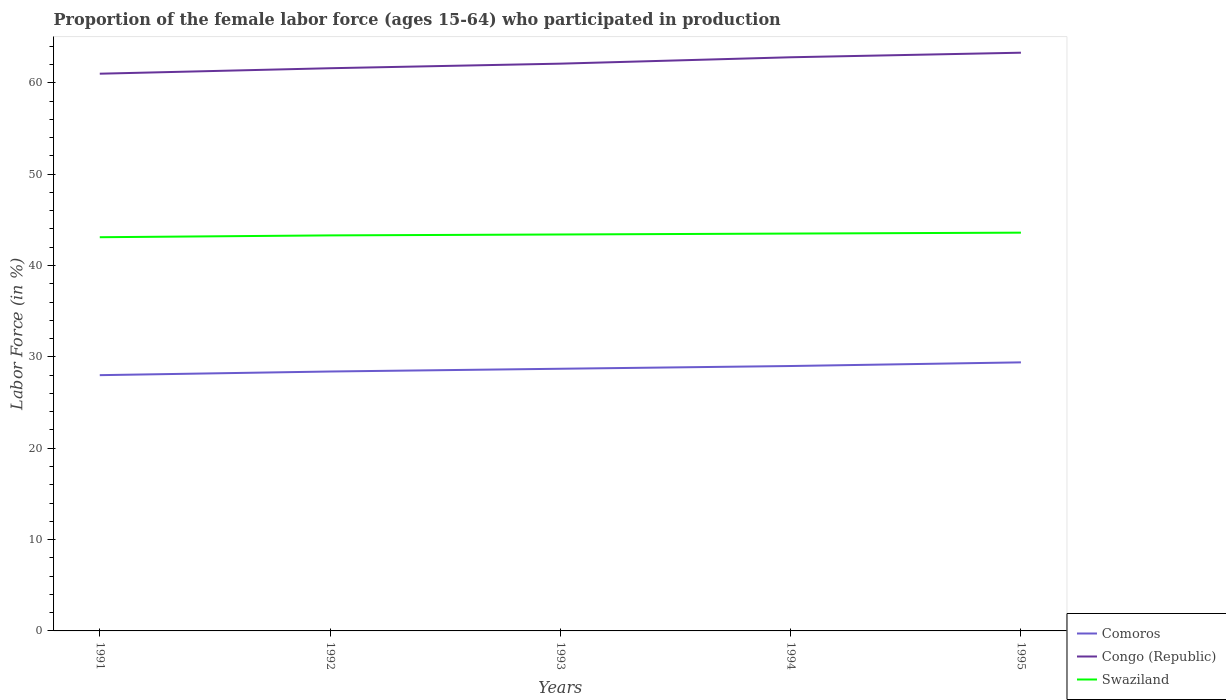Does the line corresponding to Comoros intersect with the line corresponding to Swaziland?
Keep it short and to the point. No. Is the number of lines equal to the number of legend labels?
Provide a succinct answer. Yes. Across all years, what is the maximum proportion of the female labor force who participated in production in Swaziland?
Provide a short and direct response. 43.1. In which year was the proportion of the female labor force who participated in production in Comoros maximum?
Make the answer very short. 1991. What is the total proportion of the female labor force who participated in production in Congo (Republic) in the graph?
Make the answer very short. -0.5. What is the difference between the highest and the second highest proportion of the female labor force who participated in production in Swaziland?
Keep it short and to the point. 0.5. How many legend labels are there?
Offer a terse response. 3. What is the title of the graph?
Your answer should be very brief. Proportion of the female labor force (ages 15-64) who participated in production. What is the label or title of the X-axis?
Provide a short and direct response. Years. What is the Labor Force (in %) of Swaziland in 1991?
Offer a very short reply. 43.1. What is the Labor Force (in %) in Comoros in 1992?
Your answer should be compact. 28.4. What is the Labor Force (in %) in Congo (Republic) in 1992?
Offer a very short reply. 61.6. What is the Labor Force (in %) in Swaziland in 1992?
Your answer should be compact. 43.3. What is the Labor Force (in %) in Comoros in 1993?
Make the answer very short. 28.7. What is the Labor Force (in %) of Congo (Republic) in 1993?
Provide a succinct answer. 62.1. What is the Labor Force (in %) in Swaziland in 1993?
Your answer should be compact. 43.4. What is the Labor Force (in %) in Congo (Republic) in 1994?
Offer a very short reply. 62.8. What is the Labor Force (in %) of Swaziland in 1994?
Give a very brief answer. 43.5. What is the Labor Force (in %) in Comoros in 1995?
Give a very brief answer. 29.4. What is the Labor Force (in %) of Congo (Republic) in 1995?
Keep it short and to the point. 63.3. What is the Labor Force (in %) in Swaziland in 1995?
Offer a very short reply. 43.6. Across all years, what is the maximum Labor Force (in %) of Comoros?
Keep it short and to the point. 29.4. Across all years, what is the maximum Labor Force (in %) of Congo (Republic)?
Your answer should be very brief. 63.3. Across all years, what is the maximum Labor Force (in %) in Swaziland?
Keep it short and to the point. 43.6. Across all years, what is the minimum Labor Force (in %) in Comoros?
Your response must be concise. 28. Across all years, what is the minimum Labor Force (in %) in Congo (Republic)?
Your answer should be very brief. 61. Across all years, what is the minimum Labor Force (in %) of Swaziland?
Offer a terse response. 43.1. What is the total Labor Force (in %) of Comoros in the graph?
Provide a succinct answer. 143.5. What is the total Labor Force (in %) of Congo (Republic) in the graph?
Your answer should be very brief. 310.8. What is the total Labor Force (in %) of Swaziland in the graph?
Your answer should be compact. 216.9. What is the difference between the Labor Force (in %) in Comoros in 1991 and that in 1992?
Keep it short and to the point. -0.4. What is the difference between the Labor Force (in %) of Congo (Republic) in 1991 and that in 1992?
Offer a terse response. -0.6. What is the difference between the Labor Force (in %) of Swaziland in 1991 and that in 1992?
Ensure brevity in your answer.  -0.2. What is the difference between the Labor Force (in %) in Comoros in 1991 and that in 1993?
Provide a succinct answer. -0.7. What is the difference between the Labor Force (in %) of Congo (Republic) in 1991 and that in 1993?
Offer a very short reply. -1.1. What is the difference between the Labor Force (in %) of Swaziland in 1991 and that in 1993?
Make the answer very short. -0.3. What is the difference between the Labor Force (in %) in Congo (Republic) in 1991 and that in 1994?
Your answer should be very brief. -1.8. What is the difference between the Labor Force (in %) in Comoros in 1991 and that in 1995?
Your answer should be very brief. -1.4. What is the difference between the Labor Force (in %) of Congo (Republic) in 1991 and that in 1995?
Ensure brevity in your answer.  -2.3. What is the difference between the Labor Force (in %) of Swaziland in 1991 and that in 1995?
Make the answer very short. -0.5. What is the difference between the Labor Force (in %) of Swaziland in 1992 and that in 1994?
Provide a succinct answer. -0.2. What is the difference between the Labor Force (in %) of Congo (Republic) in 1992 and that in 1995?
Provide a short and direct response. -1.7. What is the difference between the Labor Force (in %) in Congo (Republic) in 1993 and that in 1994?
Make the answer very short. -0.7. What is the difference between the Labor Force (in %) of Swaziland in 1993 and that in 1994?
Make the answer very short. -0.1. What is the difference between the Labor Force (in %) of Comoros in 1993 and that in 1995?
Offer a very short reply. -0.7. What is the difference between the Labor Force (in %) of Congo (Republic) in 1993 and that in 1995?
Offer a very short reply. -1.2. What is the difference between the Labor Force (in %) in Congo (Republic) in 1994 and that in 1995?
Provide a succinct answer. -0.5. What is the difference between the Labor Force (in %) of Swaziland in 1994 and that in 1995?
Your response must be concise. -0.1. What is the difference between the Labor Force (in %) of Comoros in 1991 and the Labor Force (in %) of Congo (Republic) in 1992?
Keep it short and to the point. -33.6. What is the difference between the Labor Force (in %) of Comoros in 1991 and the Labor Force (in %) of Swaziland in 1992?
Your answer should be very brief. -15.3. What is the difference between the Labor Force (in %) in Congo (Republic) in 1991 and the Labor Force (in %) in Swaziland in 1992?
Offer a very short reply. 17.7. What is the difference between the Labor Force (in %) of Comoros in 1991 and the Labor Force (in %) of Congo (Republic) in 1993?
Provide a succinct answer. -34.1. What is the difference between the Labor Force (in %) of Comoros in 1991 and the Labor Force (in %) of Swaziland in 1993?
Your answer should be compact. -15.4. What is the difference between the Labor Force (in %) in Comoros in 1991 and the Labor Force (in %) in Congo (Republic) in 1994?
Your answer should be very brief. -34.8. What is the difference between the Labor Force (in %) of Comoros in 1991 and the Labor Force (in %) of Swaziland in 1994?
Your answer should be very brief. -15.5. What is the difference between the Labor Force (in %) in Congo (Republic) in 1991 and the Labor Force (in %) in Swaziland in 1994?
Give a very brief answer. 17.5. What is the difference between the Labor Force (in %) in Comoros in 1991 and the Labor Force (in %) in Congo (Republic) in 1995?
Offer a very short reply. -35.3. What is the difference between the Labor Force (in %) of Comoros in 1991 and the Labor Force (in %) of Swaziland in 1995?
Make the answer very short. -15.6. What is the difference between the Labor Force (in %) of Congo (Republic) in 1991 and the Labor Force (in %) of Swaziland in 1995?
Your answer should be very brief. 17.4. What is the difference between the Labor Force (in %) in Comoros in 1992 and the Labor Force (in %) in Congo (Republic) in 1993?
Make the answer very short. -33.7. What is the difference between the Labor Force (in %) of Comoros in 1992 and the Labor Force (in %) of Swaziland in 1993?
Provide a succinct answer. -15. What is the difference between the Labor Force (in %) in Comoros in 1992 and the Labor Force (in %) in Congo (Republic) in 1994?
Your response must be concise. -34.4. What is the difference between the Labor Force (in %) in Comoros in 1992 and the Labor Force (in %) in Swaziland in 1994?
Your answer should be very brief. -15.1. What is the difference between the Labor Force (in %) in Comoros in 1992 and the Labor Force (in %) in Congo (Republic) in 1995?
Your answer should be compact. -34.9. What is the difference between the Labor Force (in %) of Comoros in 1992 and the Labor Force (in %) of Swaziland in 1995?
Your response must be concise. -15.2. What is the difference between the Labor Force (in %) in Comoros in 1993 and the Labor Force (in %) in Congo (Republic) in 1994?
Give a very brief answer. -34.1. What is the difference between the Labor Force (in %) in Comoros in 1993 and the Labor Force (in %) in Swaziland in 1994?
Your answer should be compact. -14.8. What is the difference between the Labor Force (in %) of Congo (Republic) in 1993 and the Labor Force (in %) of Swaziland in 1994?
Your answer should be very brief. 18.6. What is the difference between the Labor Force (in %) in Comoros in 1993 and the Labor Force (in %) in Congo (Republic) in 1995?
Your response must be concise. -34.6. What is the difference between the Labor Force (in %) of Comoros in 1993 and the Labor Force (in %) of Swaziland in 1995?
Offer a very short reply. -14.9. What is the difference between the Labor Force (in %) in Comoros in 1994 and the Labor Force (in %) in Congo (Republic) in 1995?
Offer a very short reply. -34.3. What is the difference between the Labor Force (in %) in Comoros in 1994 and the Labor Force (in %) in Swaziland in 1995?
Offer a very short reply. -14.6. What is the difference between the Labor Force (in %) in Congo (Republic) in 1994 and the Labor Force (in %) in Swaziland in 1995?
Give a very brief answer. 19.2. What is the average Labor Force (in %) in Comoros per year?
Make the answer very short. 28.7. What is the average Labor Force (in %) of Congo (Republic) per year?
Give a very brief answer. 62.16. What is the average Labor Force (in %) in Swaziland per year?
Provide a succinct answer. 43.38. In the year 1991, what is the difference between the Labor Force (in %) in Comoros and Labor Force (in %) in Congo (Republic)?
Offer a very short reply. -33. In the year 1991, what is the difference between the Labor Force (in %) of Comoros and Labor Force (in %) of Swaziland?
Your answer should be very brief. -15.1. In the year 1991, what is the difference between the Labor Force (in %) in Congo (Republic) and Labor Force (in %) in Swaziland?
Offer a very short reply. 17.9. In the year 1992, what is the difference between the Labor Force (in %) in Comoros and Labor Force (in %) in Congo (Republic)?
Ensure brevity in your answer.  -33.2. In the year 1992, what is the difference between the Labor Force (in %) of Comoros and Labor Force (in %) of Swaziland?
Your response must be concise. -14.9. In the year 1992, what is the difference between the Labor Force (in %) in Congo (Republic) and Labor Force (in %) in Swaziland?
Offer a terse response. 18.3. In the year 1993, what is the difference between the Labor Force (in %) of Comoros and Labor Force (in %) of Congo (Republic)?
Your response must be concise. -33.4. In the year 1993, what is the difference between the Labor Force (in %) of Comoros and Labor Force (in %) of Swaziland?
Offer a terse response. -14.7. In the year 1993, what is the difference between the Labor Force (in %) of Congo (Republic) and Labor Force (in %) of Swaziland?
Your answer should be compact. 18.7. In the year 1994, what is the difference between the Labor Force (in %) in Comoros and Labor Force (in %) in Congo (Republic)?
Your response must be concise. -33.8. In the year 1994, what is the difference between the Labor Force (in %) of Comoros and Labor Force (in %) of Swaziland?
Offer a terse response. -14.5. In the year 1994, what is the difference between the Labor Force (in %) in Congo (Republic) and Labor Force (in %) in Swaziland?
Your response must be concise. 19.3. In the year 1995, what is the difference between the Labor Force (in %) of Comoros and Labor Force (in %) of Congo (Republic)?
Provide a succinct answer. -33.9. What is the ratio of the Labor Force (in %) in Comoros in 1991 to that in 1992?
Provide a succinct answer. 0.99. What is the ratio of the Labor Force (in %) in Congo (Republic) in 1991 to that in 1992?
Keep it short and to the point. 0.99. What is the ratio of the Labor Force (in %) in Swaziland in 1991 to that in 1992?
Your answer should be very brief. 1. What is the ratio of the Labor Force (in %) in Comoros in 1991 to that in 1993?
Keep it short and to the point. 0.98. What is the ratio of the Labor Force (in %) of Congo (Republic) in 1991 to that in 1993?
Keep it short and to the point. 0.98. What is the ratio of the Labor Force (in %) of Comoros in 1991 to that in 1994?
Your response must be concise. 0.97. What is the ratio of the Labor Force (in %) of Congo (Republic) in 1991 to that in 1994?
Give a very brief answer. 0.97. What is the ratio of the Labor Force (in %) in Comoros in 1991 to that in 1995?
Make the answer very short. 0.95. What is the ratio of the Labor Force (in %) in Congo (Republic) in 1991 to that in 1995?
Your answer should be compact. 0.96. What is the ratio of the Labor Force (in %) of Swaziland in 1991 to that in 1995?
Provide a succinct answer. 0.99. What is the ratio of the Labor Force (in %) in Comoros in 1992 to that in 1993?
Provide a succinct answer. 0.99. What is the ratio of the Labor Force (in %) of Congo (Republic) in 1992 to that in 1993?
Your response must be concise. 0.99. What is the ratio of the Labor Force (in %) in Comoros in 1992 to that in 1994?
Ensure brevity in your answer.  0.98. What is the ratio of the Labor Force (in %) in Congo (Republic) in 1992 to that in 1994?
Make the answer very short. 0.98. What is the ratio of the Labor Force (in %) in Comoros in 1992 to that in 1995?
Your answer should be compact. 0.97. What is the ratio of the Labor Force (in %) in Congo (Republic) in 1992 to that in 1995?
Your answer should be compact. 0.97. What is the ratio of the Labor Force (in %) of Comoros in 1993 to that in 1994?
Provide a succinct answer. 0.99. What is the ratio of the Labor Force (in %) in Congo (Republic) in 1993 to that in 1994?
Provide a short and direct response. 0.99. What is the ratio of the Labor Force (in %) in Comoros in 1993 to that in 1995?
Your response must be concise. 0.98. What is the ratio of the Labor Force (in %) in Congo (Republic) in 1993 to that in 1995?
Provide a short and direct response. 0.98. What is the ratio of the Labor Force (in %) in Swaziland in 1993 to that in 1995?
Give a very brief answer. 1. What is the ratio of the Labor Force (in %) in Comoros in 1994 to that in 1995?
Make the answer very short. 0.99. What is the ratio of the Labor Force (in %) of Swaziland in 1994 to that in 1995?
Offer a terse response. 1. What is the difference between the highest and the second highest Labor Force (in %) in Swaziland?
Provide a short and direct response. 0.1. What is the difference between the highest and the lowest Labor Force (in %) in Swaziland?
Keep it short and to the point. 0.5. 